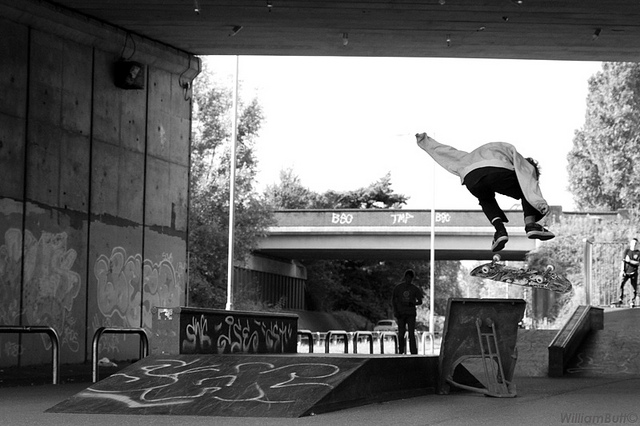Please transcribe the text in this image. Williom Butts 